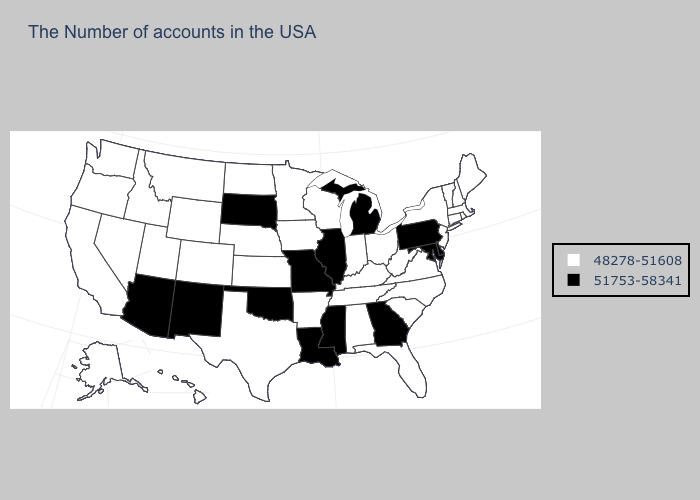Among the states that border Maryland , does Virginia have the lowest value?
Give a very brief answer. Yes. Which states have the lowest value in the USA?
Give a very brief answer. Maine, Massachusetts, Rhode Island, New Hampshire, Vermont, Connecticut, New York, New Jersey, Virginia, North Carolina, South Carolina, West Virginia, Ohio, Florida, Kentucky, Indiana, Alabama, Tennessee, Wisconsin, Arkansas, Minnesota, Iowa, Kansas, Nebraska, Texas, North Dakota, Wyoming, Colorado, Utah, Montana, Idaho, Nevada, California, Washington, Oregon, Alaska, Hawaii. What is the value of Missouri?
Answer briefly. 51753-58341. Does Rhode Island have the highest value in the USA?
Be succinct. No. Among the states that border Utah , which have the lowest value?
Write a very short answer. Wyoming, Colorado, Idaho, Nevada. Name the states that have a value in the range 48278-51608?
Keep it brief. Maine, Massachusetts, Rhode Island, New Hampshire, Vermont, Connecticut, New York, New Jersey, Virginia, North Carolina, South Carolina, West Virginia, Ohio, Florida, Kentucky, Indiana, Alabama, Tennessee, Wisconsin, Arkansas, Minnesota, Iowa, Kansas, Nebraska, Texas, North Dakota, Wyoming, Colorado, Utah, Montana, Idaho, Nevada, California, Washington, Oregon, Alaska, Hawaii. Does Georgia have the highest value in the USA?
Write a very short answer. Yes. What is the value of Idaho?
Be succinct. 48278-51608. What is the highest value in the MidWest ?
Concise answer only. 51753-58341. Name the states that have a value in the range 48278-51608?
Quick response, please. Maine, Massachusetts, Rhode Island, New Hampshire, Vermont, Connecticut, New York, New Jersey, Virginia, North Carolina, South Carolina, West Virginia, Ohio, Florida, Kentucky, Indiana, Alabama, Tennessee, Wisconsin, Arkansas, Minnesota, Iowa, Kansas, Nebraska, Texas, North Dakota, Wyoming, Colorado, Utah, Montana, Idaho, Nevada, California, Washington, Oregon, Alaska, Hawaii. Among the states that border Arkansas , which have the highest value?
Be succinct. Mississippi, Louisiana, Missouri, Oklahoma. Does Florida have the highest value in the South?
Give a very brief answer. No. Name the states that have a value in the range 51753-58341?
Write a very short answer. Delaware, Maryland, Pennsylvania, Georgia, Michigan, Illinois, Mississippi, Louisiana, Missouri, Oklahoma, South Dakota, New Mexico, Arizona. Does the map have missing data?
Keep it brief. No. Does Minnesota have a lower value than North Dakota?
Answer briefly. No. 